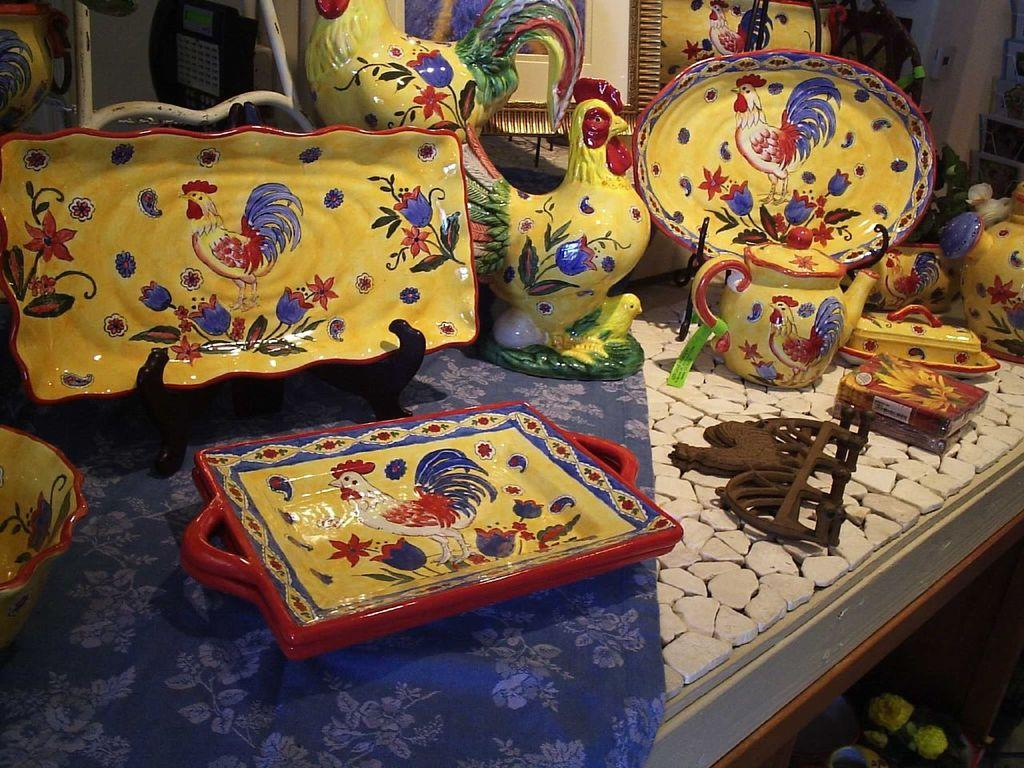What type of dishes can be seen in the image? There are several handmade dishes in the image. Where are the dishes placed? The dishes are kept on a table. Can you describe one of the dishes in detail? There is a brown plate with a beautiful painting in the image. How many sugar cubes are on the brown plate with the beautiful painting? There is no mention of sugar cubes in the image, so it is impossible to determine their quantity. 